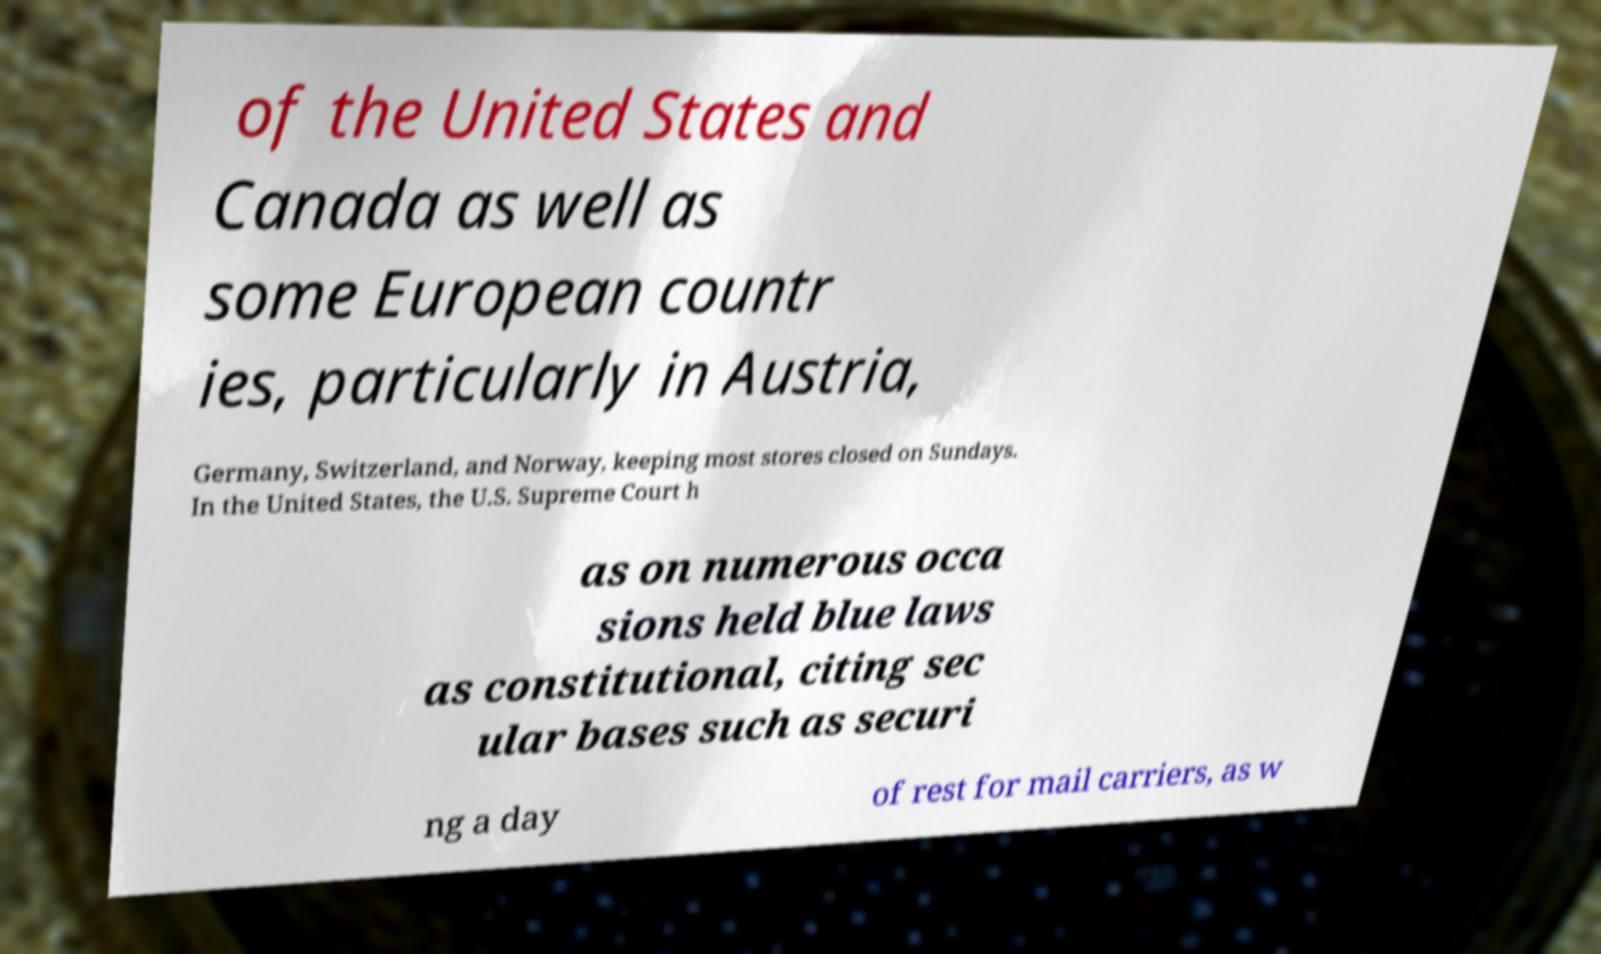There's text embedded in this image that I need extracted. Can you transcribe it verbatim? of the United States and Canada as well as some European countr ies, particularly in Austria, Germany, Switzerland, and Norway, keeping most stores closed on Sundays. In the United States, the U.S. Supreme Court h as on numerous occa sions held blue laws as constitutional, citing sec ular bases such as securi ng a day of rest for mail carriers, as w 